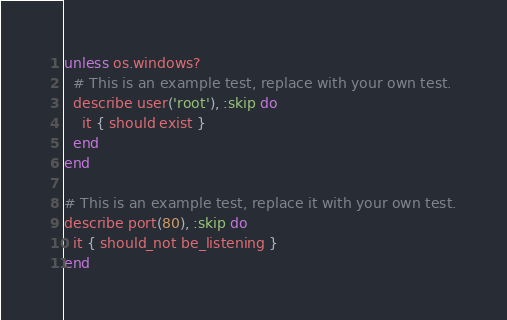Convert code to text. <code><loc_0><loc_0><loc_500><loc_500><_Ruby_>unless os.windows?
  # This is an example test, replace with your own test.
  describe user('root'), :skip do
    it { should exist }
  end
end

# This is an example test, replace it with your own test.
describe port(80), :skip do
  it { should_not be_listening }
end
</code> 